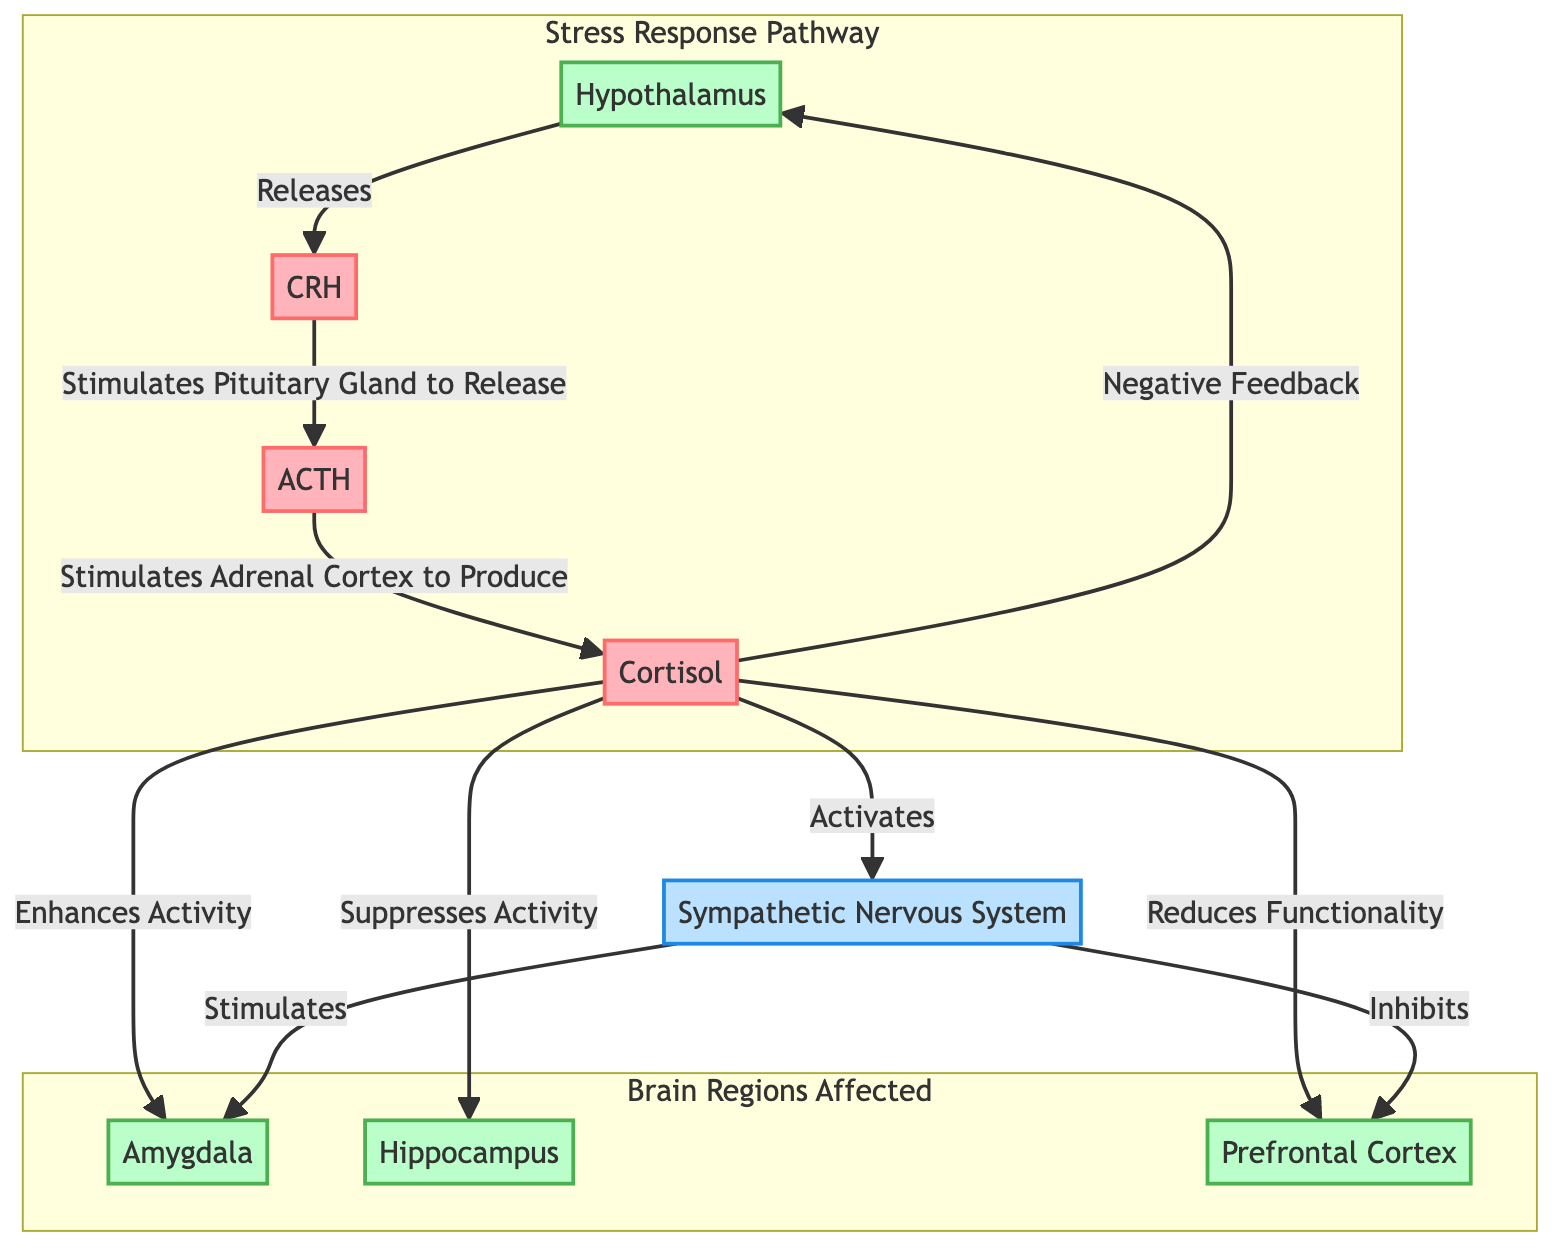What hormone does the hypothalamus release? The diagram shows that the hypothalamus releases CRH, as indicated by the arrow pointing from the hypothalamus to CRH.
Answer: CRH Which brain region is activated by cortisol? The diagram illustrates that cortisol enhances activity in the amygdala, as shown by the direct link from cortisol to amygdala with the label "Enhances Activity."
Answer: Amygdala How many brain regions are affected by cortisol? By examining the diagram, we see three brain regions listed (amygdala, hippocampus, and prefrontal cortex) that are influenced by cortisol, indicated by the labels and connections.
Answer: Three What is the effect of cortisol on the hippocampus? The diagram specifies that cortisol suppresses activity in the hippocampus through the labeled connection from cortisol to hippocampus indicating "Suppresses Activity."
Answer: Suppresses Activity What kind of feedback does cortisol provide to the hypothalamus? The diagram states there is a negative feedback from cortisol to the hypothalamus, shown by the connection labeled "Negative Feedback."
Answer: Negative Feedback Which system is activated by cortisol? According to the diagram, cortisol activates the sympathetic nervous system, as portrayed by the arrow pointing from cortisol to the nervous system with the label "Activates."
Answer: Sympathetic Nervous System What is the relationship between the sympathetic nervous system and the amygdala? The diagram indicates that the sympathetic nervous system stimulates the amygdala, as shown by the arrow labeled "Stimulates" going from SNS to the amygdala.
Answer: Stimulates What is the role of CRH in the stress response pathway? The diagram illustrates that CRH stimulates the pituitary gland to release ACTH, thereby playing a crucial role in the stress response pathway. This is indicated by the connection from CRH to ACTH with the label "Stimulates Pituitary Gland to Release."
Answer: Stimulates Pituitary Gland to Release How does cortisol impact the prefrontal cortex? The diagram indicates that cortisol reduces functionality in the prefrontal cortex, with a direct connection labeled "Reduces Functionality" linking cortisol to the prefrontal cortex.
Answer: Reduces Functionality 